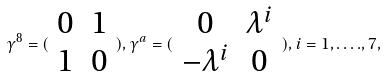<formula> <loc_0><loc_0><loc_500><loc_500>\gamma ^ { 8 } = ( \begin{array} { c c } 0 & 1 \\ 1 & 0 \end{array} ) , \gamma ^ { a } = ( \begin{array} { c c } 0 & \lambda ^ { i } \\ - \lambda ^ { i } & 0 \end{array} ) , i = 1 , \dots . , 7 ,</formula> 